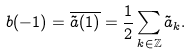Convert formula to latex. <formula><loc_0><loc_0><loc_500><loc_500>b ( - 1 ) = \overline { \tilde { a } ( 1 ) } = \frac { 1 } { 2 } \sum _ { k \in \mathbb { Z } } \tilde { a } _ { k } .</formula> 